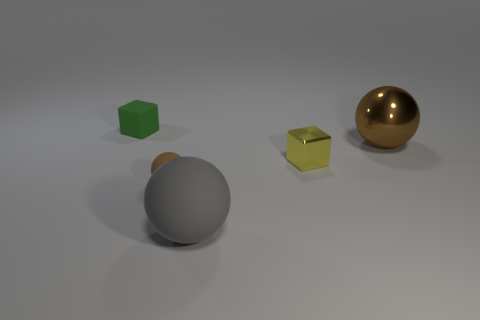What textures are visible on the surfaces of the objects depicted? The green cube has a matte texture, the gray sphere has a slight metallic sheen, the smaller yellow cube appears somewhat reflective like the gray sphere, and the golden sphere has a highly reflective, almost mirror-like texture. 